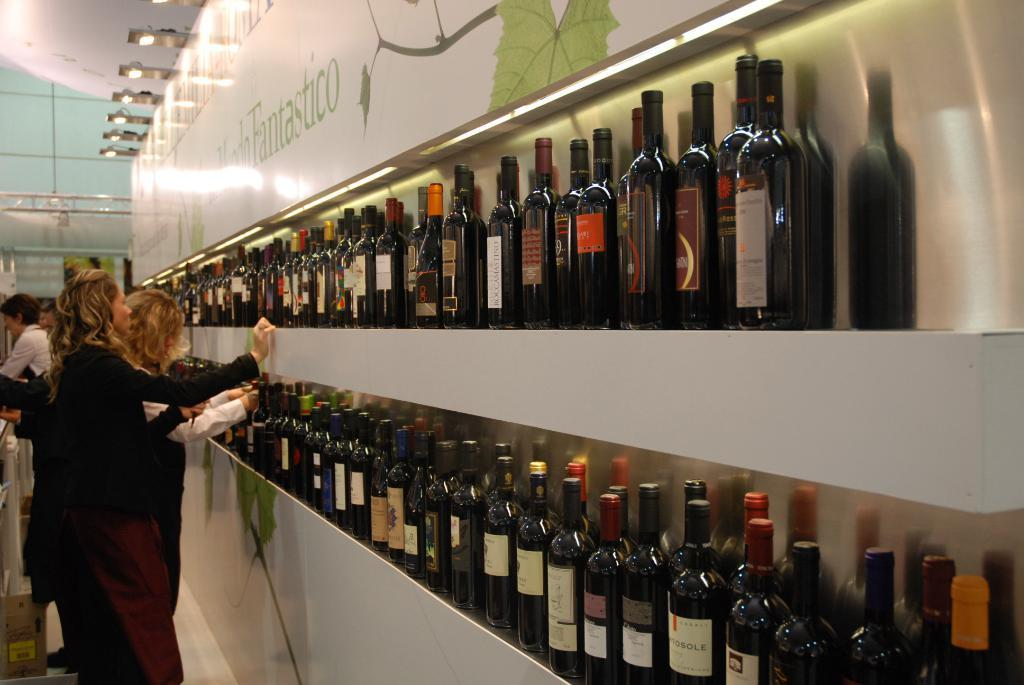What objects can be seen on the shelves in the image? There are bottles placed in the shelves. What is happening on the left side of the image? There are people on the left side of the image. What can be seen in the background of the image? There is a board and lights visible in the background of the image. What type of paper is being used to cover the apparatus in the image? There is no apparatus or paper present in the image. What is the source of shame for the people in the image? There is no indication of shame or any apparatus in the image. 